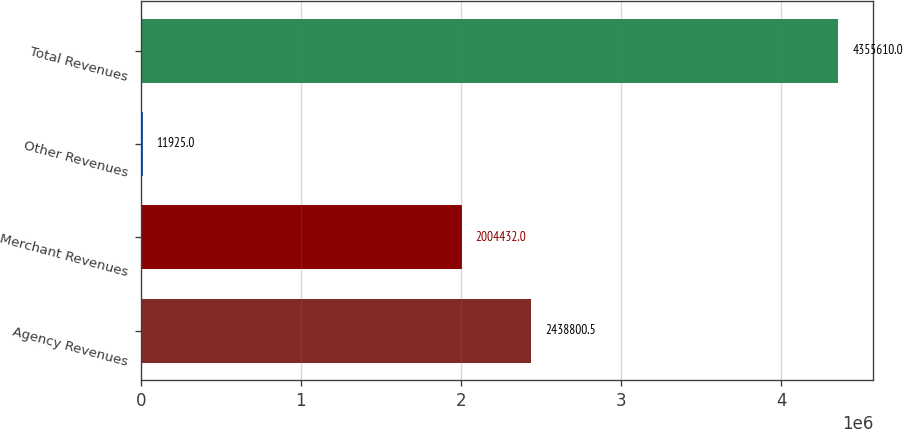Convert chart to OTSL. <chart><loc_0><loc_0><loc_500><loc_500><bar_chart><fcel>Agency Revenues<fcel>Merchant Revenues<fcel>Other Revenues<fcel>Total Revenues<nl><fcel>2.4388e+06<fcel>2.00443e+06<fcel>11925<fcel>4.35561e+06<nl></chart> 